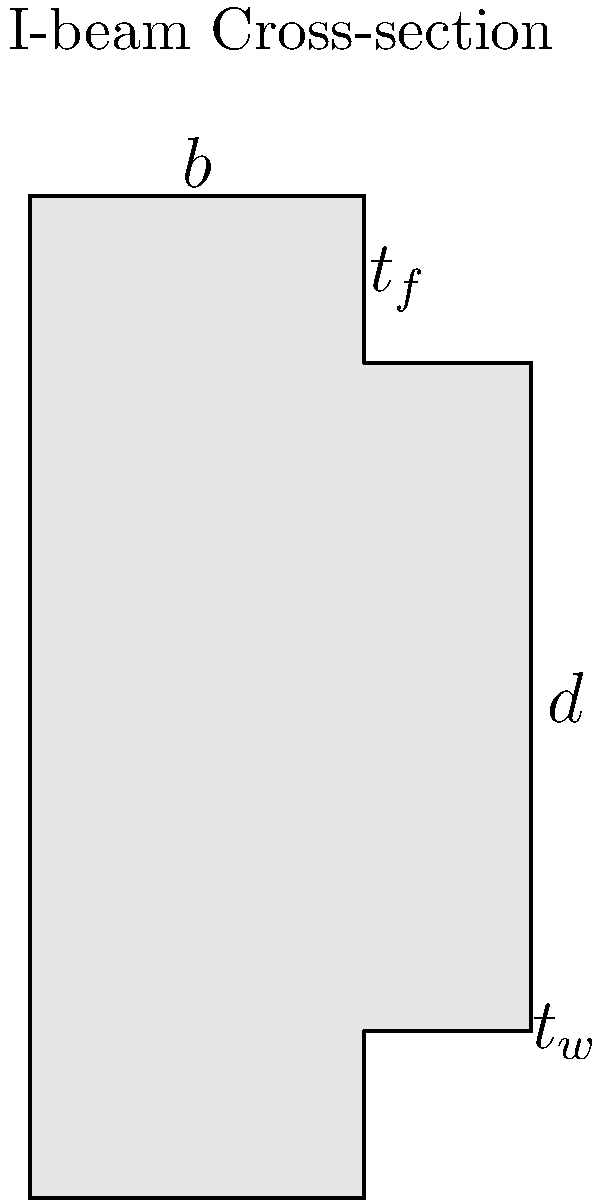In your vast collection of Alexander Pope's poetry, you come across a peculiar bookmark shaped like an I-beam. Intrigued, you decide to calculate its moment of inertia. Given an I-beam with flange width $b = 4$ inches, depth $d = 6$ inches, web thickness $t_w = 0.25$ inches, and flange thickness $t_f = 0.5$ inches, what is the moment of inertia $I_x$ about the x-axis (in $\text{in}^4$)? To calculate the moment of inertia $I_x$ for the I-beam, we'll follow these steps:

1) First, divide the I-beam into three rectangles: two flanges and one web.

2) Calculate the moment of inertia for each rectangle using the formula:
   $$I = \frac{bh^3}{12} + Ad^2$$
   where $b$ is the base, $h$ is the height, $A$ is the area, and $d$ is the distance from the centroid to the neutral axis.

3) For the top and bottom flanges:
   $b = 4$ in, $h = 0.5$ in, $A = 4 \times 0.5 = 2$ in², $d = (6-0.5)/2 = 2.75$ in
   $$I_f = \frac{4 \times 0.5^3}{12} + 2 \times 2.75^2 = 0.0417 + 15.125 = 15.1667 \text{ in}^4$$
   For both flanges: $2 \times 15.1667 = 30.3334 \text{ in}^4$

4) For the web:
   $b = 0.25$ in, $h = 5$ in (depth minus flange thicknesses)
   $$I_w = \frac{0.25 \times 5^3}{12} = 2.6042 \text{ in}^4$$

5) Sum the moments of inertia:
   $$I_x = 30.3334 + 2.6042 = 32.9376 \text{ in}^4$$

6) Round to three decimal places: $32.938 \text{ in}^4$
Answer: $32.938 \text{ in}^4$ 